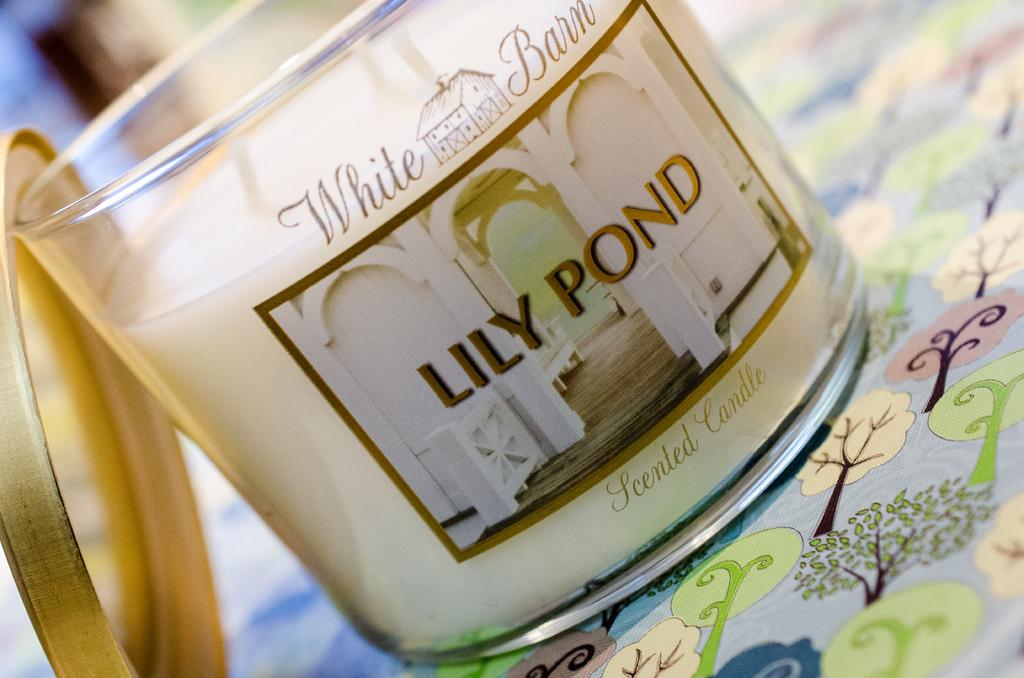<image>
Relay a brief, clear account of the picture shown. A Lily Bond white barn candle with the cap off. 